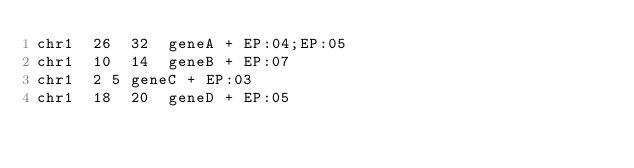<code> <loc_0><loc_0><loc_500><loc_500><_SQL_>chr1	26	32	geneA	+	EP:04;EP:05
chr1	10	14	geneB	+	EP:07
chr1	2	5	geneC	+	EP:03
chr1	18	20	geneD	+	EP:05
</code> 